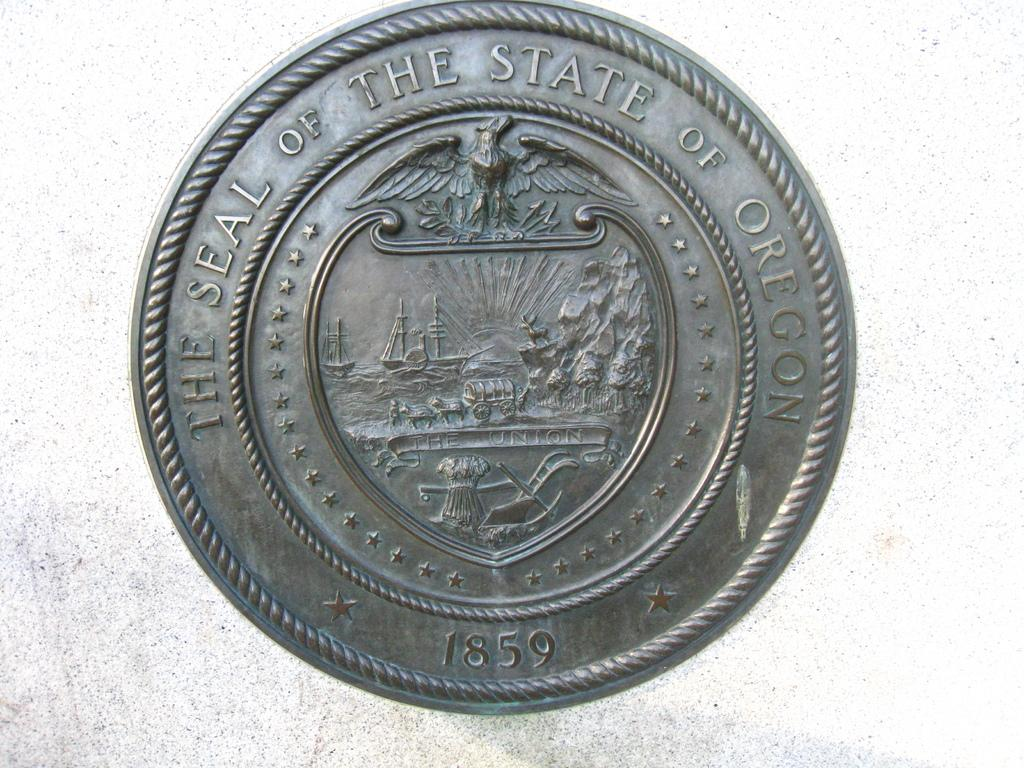<image>
Create a compact narrative representing the image presented. A silver coin with the imprint 1859 on the bottom and the words, The Seal of the State of Oregon imprinted on the top. 